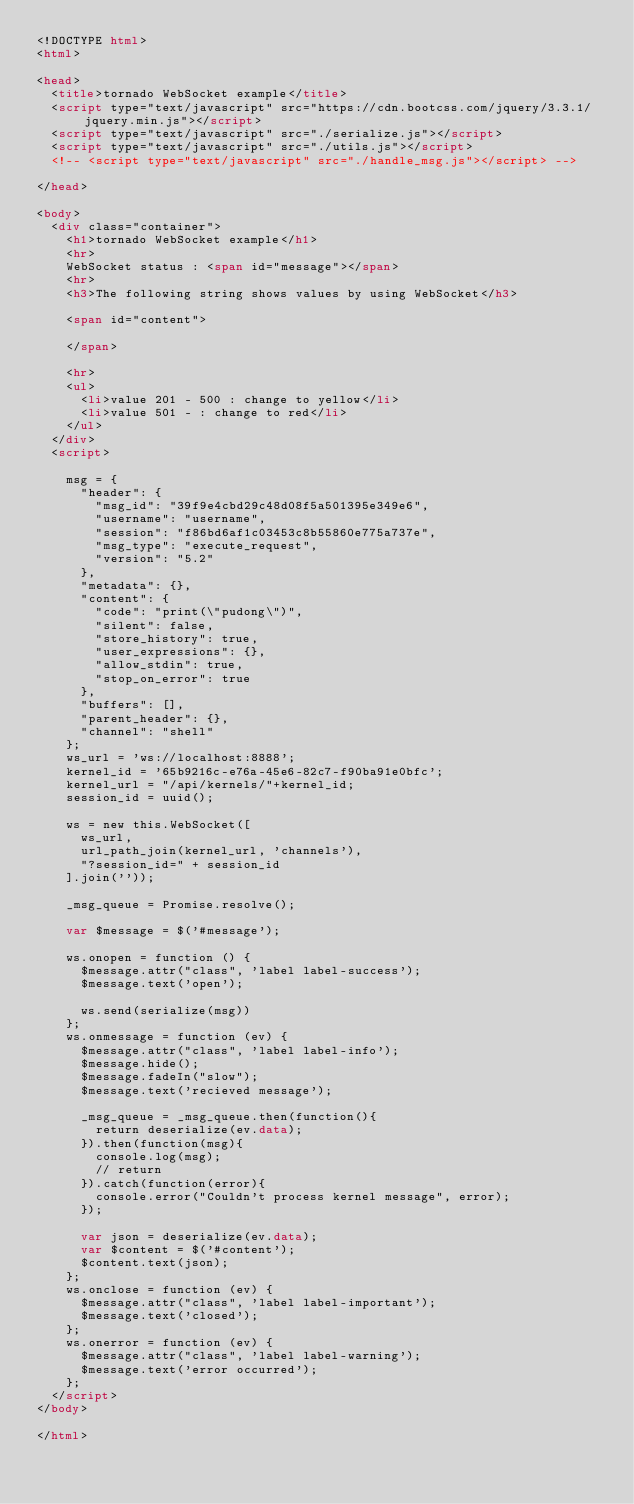<code> <loc_0><loc_0><loc_500><loc_500><_HTML_><!DOCTYPE html>
<html>

<head>
  <title>tornado WebSocket example</title>
  <script type="text/javascript" src="https://cdn.bootcss.com/jquery/3.3.1/jquery.min.js"></script>
  <script type="text/javascript" src="./serialize.js"></script>
  <script type="text/javascript" src="./utils.js"></script>
  <!-- <script type="text/javascript" src="./handle_msg.js"></script> -->

</head>

<body>
  <div class="container">
    <h1>tornado WebSocket example</h1>
    <hr>
    WebSocket status : <span id="message"></span>
    <hr>
    <h3>The following string shows values by using WebSocket</h3>

    <span id="content">

    </span>

    <hr>
    <ul>
      <li>value 201 - 500 : change to yellow</li>
      <li>value 501 - : change to red</li>
    </ul>
  </div>
  <script>
    
    msg = {
      "header": {
        "msg_id": "39f9e4cbd29c48d08f5a501395e349e6",
        "username": "username",
        "session": "f86bd6af1c03453c8b55860e775a737e",
        "msg_type": "execute_request",
        "version": "5.2"
      },
      "metadata": {},
      "content": {
        "code": "print(\"pudong\")",
        "silent": false,
        "store_history": true,
        "user_expressions": {},
        "allow_stdin": true,
        "stop_on_error": true
      },
      "buffers": [],
      "parent_header": {},
      "channel": "shell"
    };
    ws_url = 'ws://localhost:8888';
    kernel_id = '65b9216c-e76a-45e6-82c7-f90ba91e0bfc';
    kernel_url = "/api/kernels/"+kernel_id;
    session_id = uuid();

    ws = new this.WebSocket([
      ws_url,
      url_path_join(kernel_url, 'channels'),
      "?session_id=" + session_id
    ].join(''));

    _msg_queue = Promise.resolve();
    
    var $message = $('#message');

    ws.onopen = function () {
      $message.attr("class", 'label label-success');
      $message.text('open');

      ws.send(serialize(msg))
    };
    ws.onmessage = function (ev) {
      $message.attr("class", 'label label-info');
      $message.hide();
      $message.fadeIn("slow");
      $message.text('recieved message');

      _msg_queue = _msg_queue.then(function(){
        return deserialize(ev.data);
      }).then(function(msg){
        console.log(msg);
        // return 
      }).catch(function(error){
        console.error("Couldn't process kernel message", error);
      });

      var json = deserialize(ev.data);
      var $content = $('#content');
      $content.text(json);
    };
    ws.onclose = function (ev) {
      $message.attr("class", 'label label-important');
      $message.text('closed');
    };
    ws.onerror = function (ev) {
      $message.attr("class", 'label label-warning');
      $message.text('error occurred');
    };
  </script>
</body>

</html></code> 